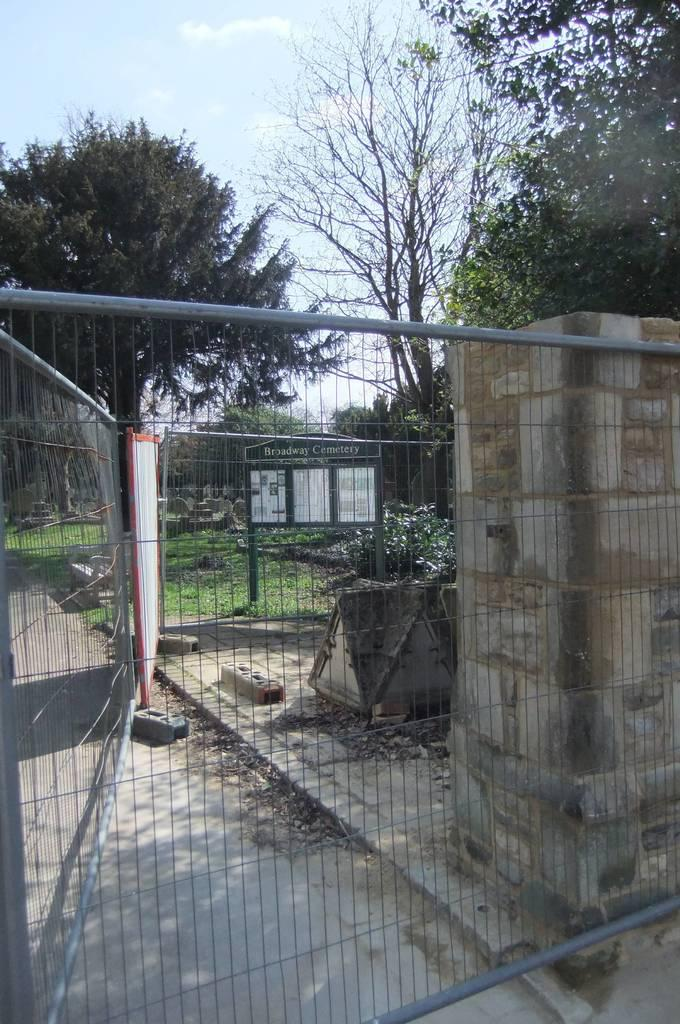What type of structure can be seen in the image? There are railings and a pillar in the image, which suggests a structure such as a building or bridge. What else is present in the image besides the railings and pillar? There is a board with poles in the image. What can be seen in the background of the image? Trees and the sky are visible in the background of the image. How many cabbages are hanging from the railings in the image? There are no cabbages present in the image; it features railings, a pillar, and a board with poles. What is the age range of the children playing near the pillar in the image? There are no children present in the image; it features railings, a pillar, and a board with poles. 